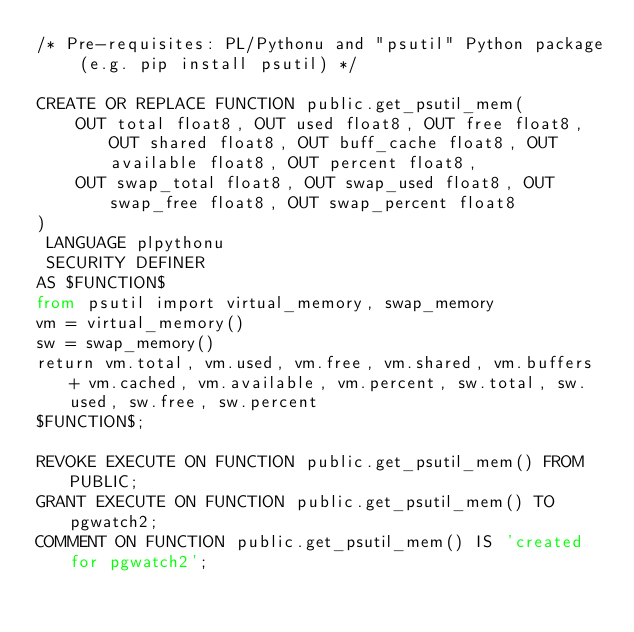<code> <loc_0><loc_0><loc_500><loc_500><_SQL_>/* Pre-requisites: PL/Pythonu and "psutil" Python package (e.g. pip install psutil) */

CREATE OR REPLACE FUNCTION public.get_psutil_mem(
	OUT total float8, OUT used float8, OUT free float8, OUT shared float8, OUT buff_cache float8, OUT available float8, OUT percent float8,
	OUT swap_total float8, OUT swap_used float8, OUT swap_free float8, OUT swap_percent float8
)
 LANGUAGE plpythonu
 SECURITY DEFINER
AS $FUNCTION$
from psutil import virtual_memory, swap_memory
vm = virtual_memory()
sw = swap_memory()
return vm.total, vm.used, vm.free, vm.shared, vm.buffers + vm.cached, vm.available, vm.percent, sw.total, sw.used, sw.free, sw.percent
$FUNCTION$;

REVOKE EXECUTE ON FUNCTION public.get_psutil_mem() FROM PUBLIC;
GRANT EXECUTE ON FUNCTION public.get_psutil_mem() TO pgwatch2;
COMMENT ON FUNCTION public.get_psutil_mem() IS 'created for pgwatch2';
</code> 